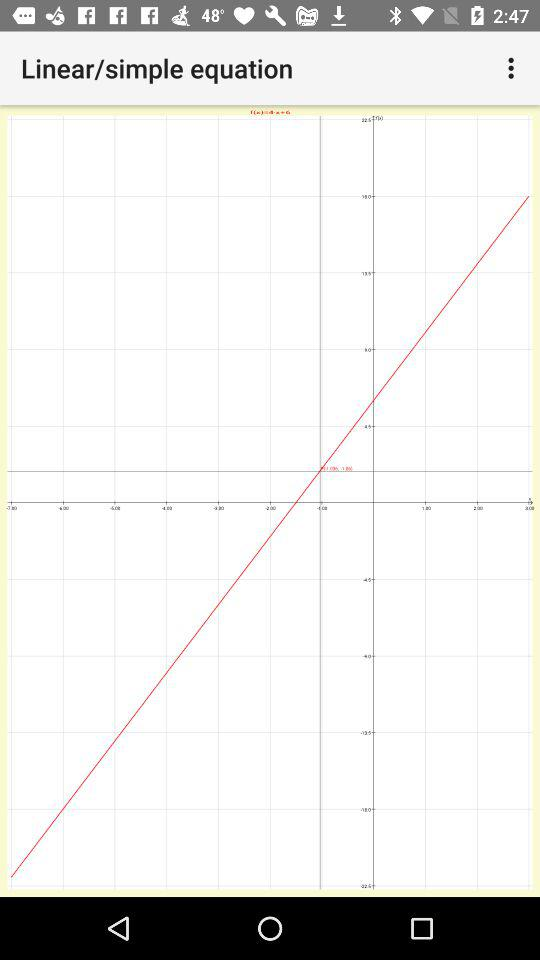What is the name of this equation?
When the provided information is insufficient, respond with <no answer>. <no answer> 